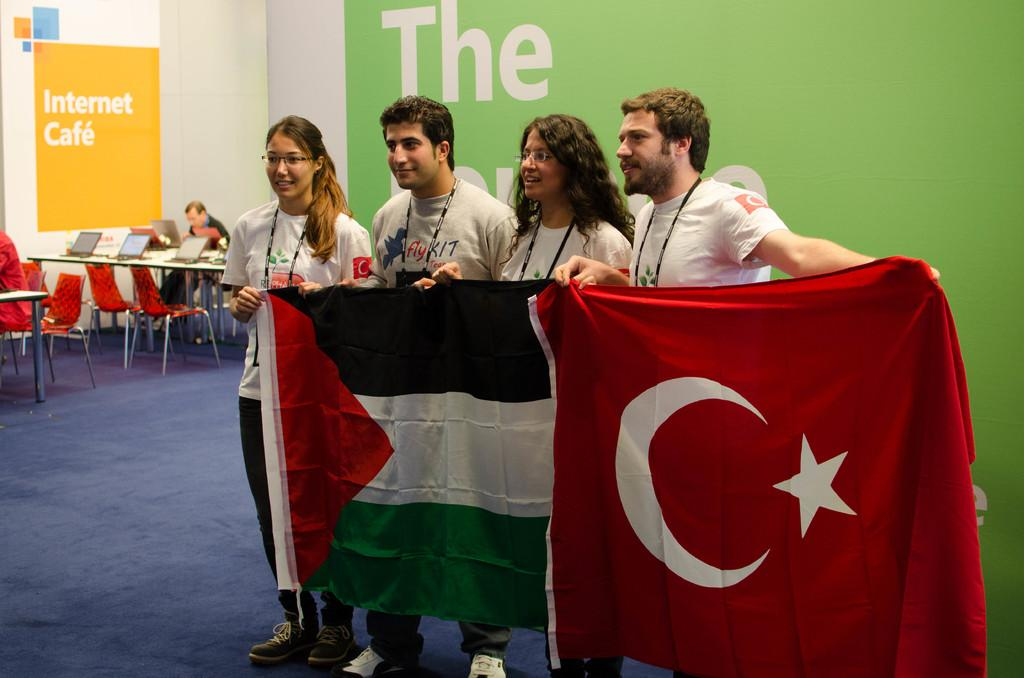What is the main subject of the image? The main subject of the image is a group of men. What are the men holding in the image? The men are holding a flag in the image. What type of furniture is present in the image? There is a table and chairs in the image. What type of fuel can be seen powering the toy car in the image? There is no toy car or fuel present in the image. 